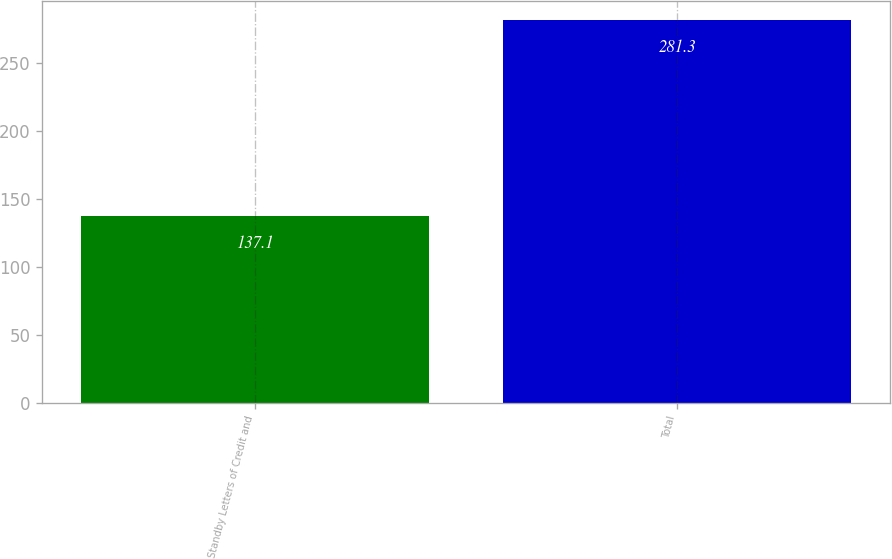Convert chart. <chart><loc_0><loc_0><loc_500><loc_500><bar_chart><fcel>Standby Letters of Credit and<fcel>Total<nl><fcel>137.1<fcel>281.3<nl></chart> 